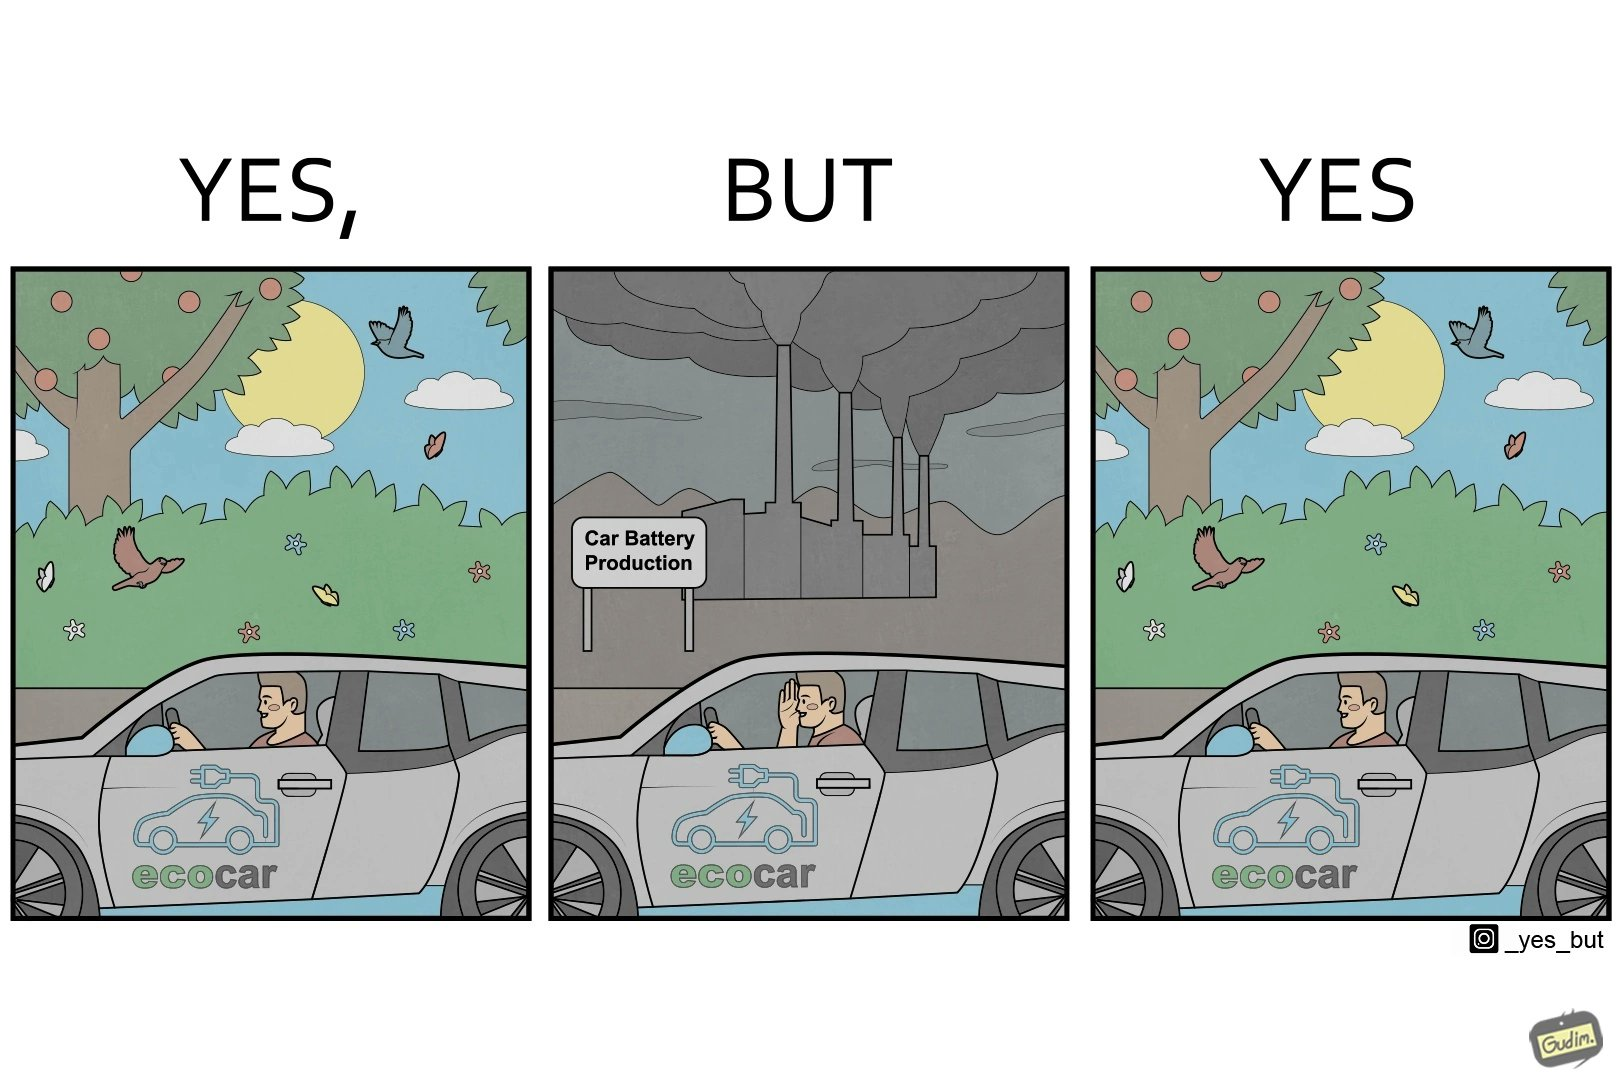Compare the left and right sides of this image. In the left part of the image: Image showing how using electric powered vehicles helps make the world a greener place In the right part of the image: Image showing the vast amount of pollution caused during production of batteries 